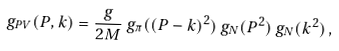Convert formula to latex. <formula><loc_0><loc_0><loc_500><loc_500>g _ { P V } ( P , k ) = \frac { g } { 2 M } \, g _ { \pi } ( ( P - k ) ^ { 2 } ) \, g _ { N } ( P ^ { 2 } ) \, g _ { N } ( k ^ { 2 } ) \, ,</formula> 